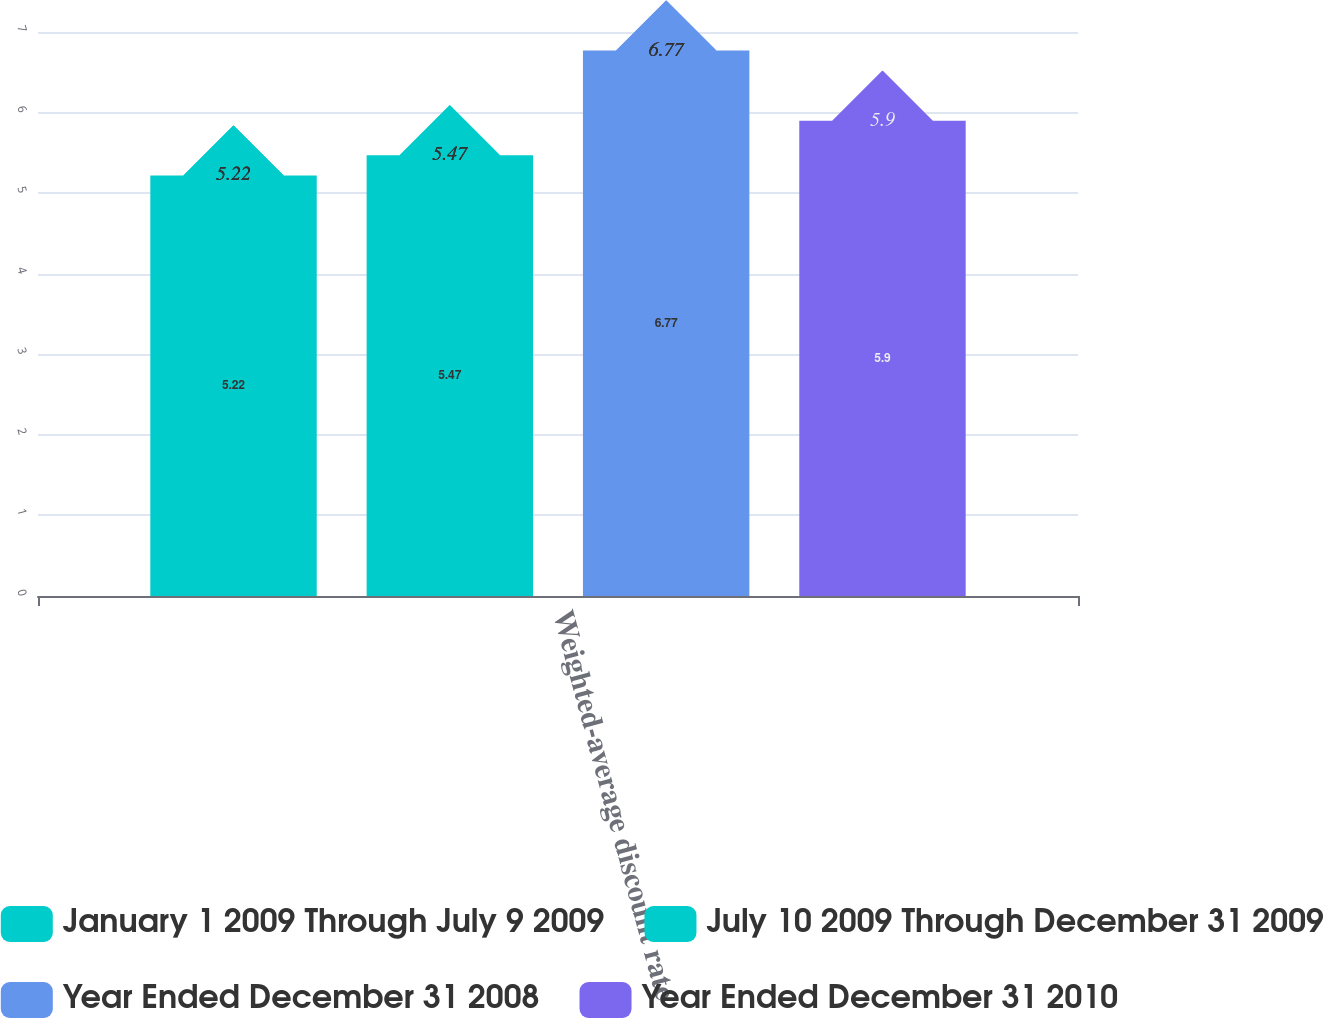Convert chart to OTSL. <chart><loc_0><loc_0><loc_500><loc_500><stacked_bar_chart><ecel><fcel>Weighted-average discount rate<nl><fcel>January 1 2009 Through July 9 2009<fcel>5.22<nl><fcel>July 10 2009 Through December 31 2009<fcel>5.47<nl><fcel>Year Ended December 31 2008<fcel>6.77<nl><fcel>Year Ended December 31 2010<fcel>5.9<nl></chart> 